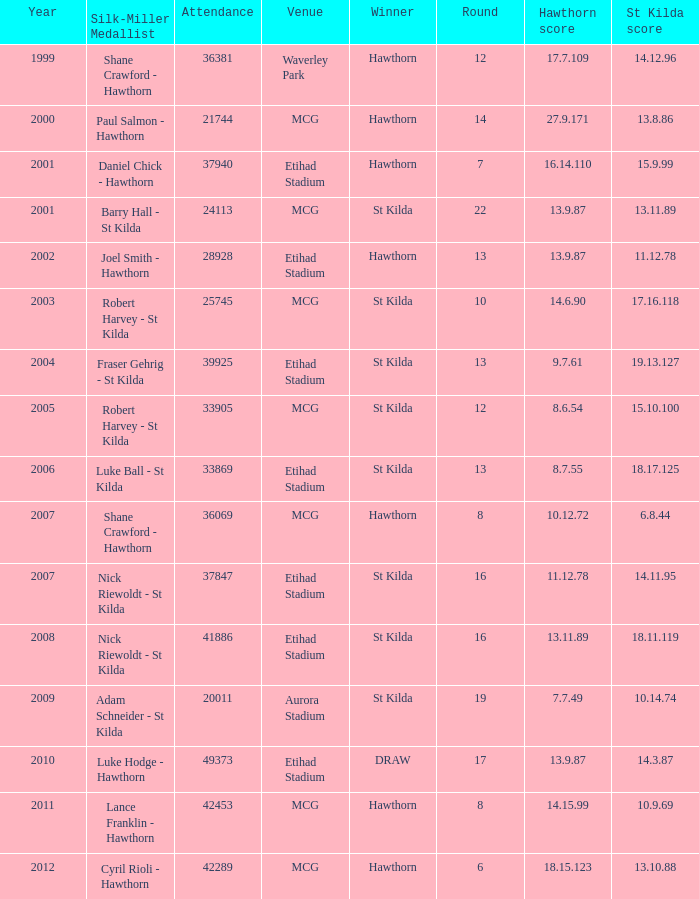What is the attendance when the st kilda score is 13.10.88? 42289.0. 